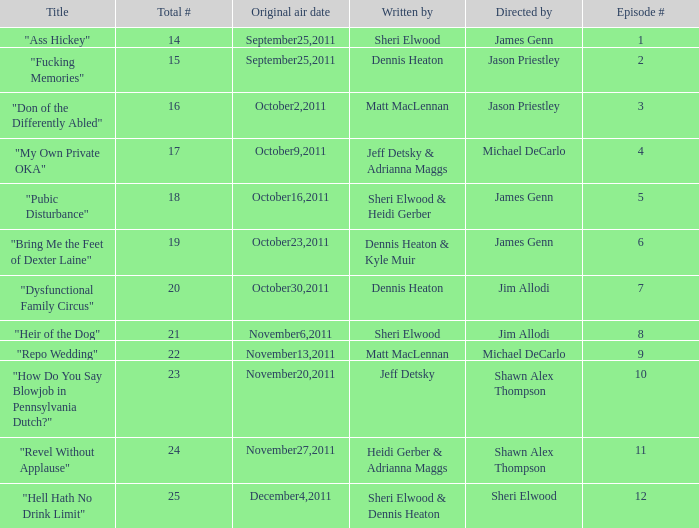How many different episode numbers does the episode written by Sheri Elwood and directed by Jim Allodi have? 1.0. 